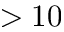<formula> <loc_0><loc_0><loc_500><loc_500>> 1 0</formula> 